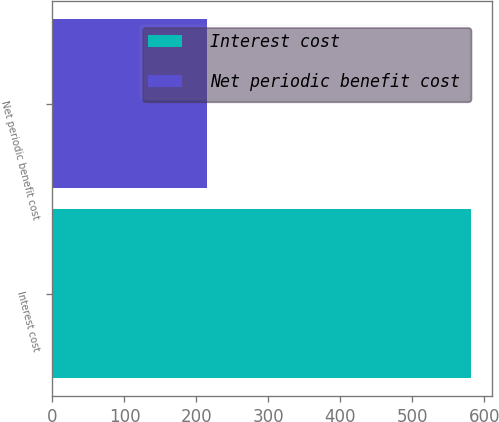Convert chart to OTSL. <chart><loc_0><loc_0><loc_500><loc_500><bar_chart><fcel>Interest cost<fcel>Net periodic benefit cost<nl><fcel>581<fcel>215<nl></chart> 